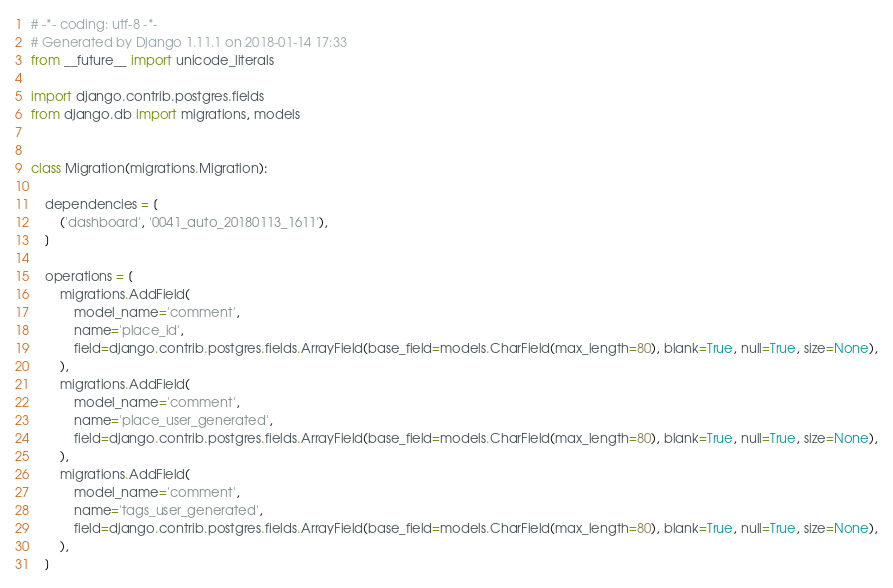Convert code to text. <code><loc_0><loc_0><loc_500><loc_500><_Python_># -*- coding: utf-8 -*-
# Generated by Django 1.11.1 on 2018-01-14 17:33
from __future__ import unicode_literals

import django.contrib.postgres.fields
from django.db import migrations, models


class Migration(migrations.Migration):

    dependencies = [
        ('dashboard', '0041_auto_20180113_1611'),
    ]

    operations = [
        migrations.AddField(
            model_name='comment',
            name='place_id',
            field=django.contrib.postgres.fields.ArrayField(base_field=models.CharField(max_length=80), blank=True, null=True, size=None),
        ),
        migrations.AddField(
            model_name='comment',
            name='place_user_generated',
            field=django.contrib.postgres.fields.ArrayField(base_field=models.CharField(max_length=80), blank=True, null=True, size=None),
        ),
        migrations.AddField(
            model_name='comment',
            name='tags_user_generated',
            field=django.contrib.postgres.fields.ArrayField(base_field=models.CharField(max_length=80), blank=True, null=True, size=None),
        ),
    ]
</code> 